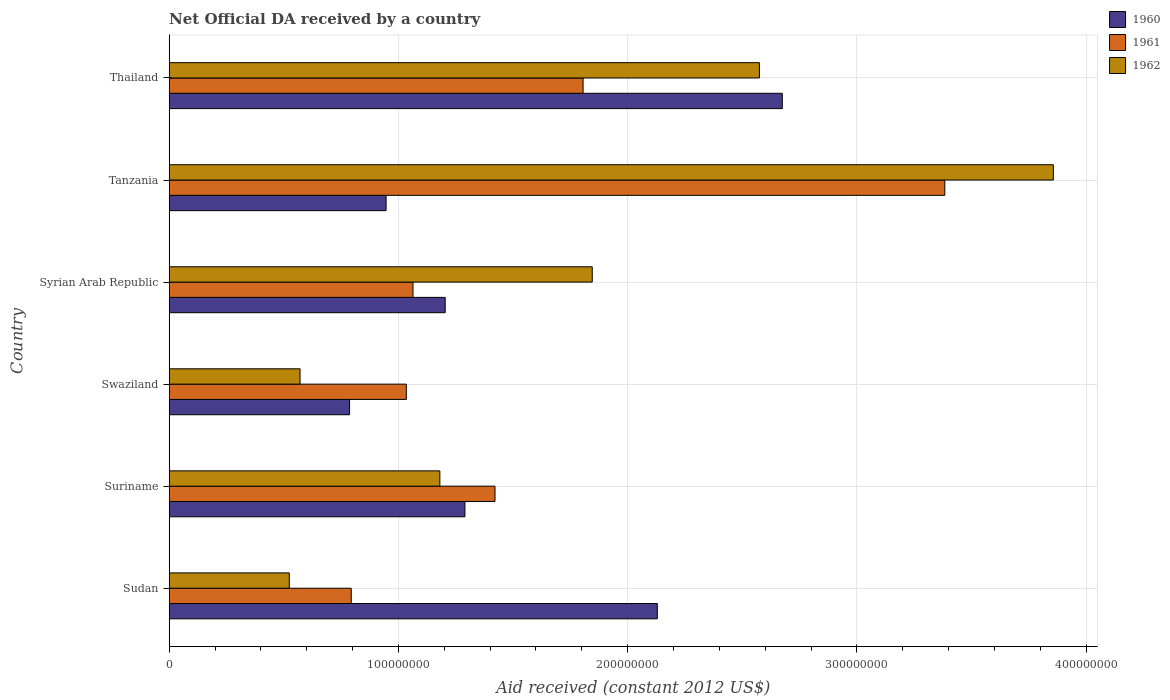How many different coloured bars are there?
Make the answer very short. 3. Are the number of bars per tick equal to the number of legend labels?
Provide a short and direct response. Yes. Are the number of bars on each tick of the Y-axis equal?
Keep it short and to the point. Yes. What is the label of the 5th group of bars from the top?
Keep it short and to the point. Suriname. In how many cases, is the number of bars for a given country not equal to the number of legend labels?
Give a very brief answer. 0. What is the net official development assistance aid received in 1961 in Syrian Arab Republic?
Ensure brevity in your answer.  1.06e+08. Across all countries, what is the maximum net official development assistance aid received in 1960?
Your answer should be very brief. 2.67e+08. Across all countries, what is the minimum net official development assistance aid received in 1960?
Make the answer very short. 7.87e+07. In which country was the net official development assistance aid received in 1961 maximum?
Provide a short and direct response. Tanzania. In which country was the net official development assistance aid received in 1960 minimum?
Make the answer very short. Swaziland. What is the total net official development assistance aid received in 1961 in the graph?
Keep it short and to the point. 9.50e+08. What is the difference between the net official development assistance aid received in 1961 in Sudan and that in Thailand?
Make the answer very short. -1.01e+08. What is the difference between the net official development assistance aid received in 1961 in Thailand and the net official development assistance aid received in 1962 in Suriname?
Your answer should be very brief. 6.25e+07. What is the average net official development assistance aid received in 1960 per country?
Ensure brevity in your answer.  1.51e+08. What is the difference between the net official development assistance aid received in 1962 and net official development assistance aid received in 1960 in Sudan?
Offer a terse response. -1.61e+08. What is the ratio of the net official development assistance aid received in 1960 in Swaziland to that in Thailand?
Offer a terse response. 0.29. Is the net official development assistance aid received in 1962 in Sudan less than that in Syrian Arab Republic?
Make the answer very short. Yes. What is the difference between the highest and the second highest net official development assistance aid received in 1960?
Give a very brief answer. 5.45e+07. What is the difference between the highest and the lowest net official development assistance aid received in 1960?
Ensure brevity in your answer.  1.89e+08. Is the sum of the net official development assistance aid received in 1962 in Sudan and Thailand greater than the maximum net official development assistance aid received in 1960 across all countries?
Make the answer very short. Yes. What does the 3rd bar from the top in Swaziland represents?
Make the answer very short. 1960. What does the 1st bar from the bottom in Thailand represents?
Your response must be concise. 1960. Are all the bars in the graph horizontal?
Provide a succinct answer. Yes. How many countries are there in the graph?
Your answer should be very brief. 6. Are the values on the major ticks of X-axis written in scientific E-notation?
Offer a very short reply. No. Does the graph contain any zero values?
Ensure brevity in your answer.  No. Does the graph contain grids?
Make the answer very short. Yes. How many legend labels are there?
Keep it short and to the point. 3. How are the legend labels stacked?
Provide a short and direct response. Vertical. What is the title of the graph?
Your response must be concise. Net Official DA received by a country. What is the label or title of the X-axis?
Provide a succinct answer. Aid received (constant 2012 US$). What is the Aid received (constant 2012 US$) of 1960 in Sudan?
Provide a succinct answer. 2.13e+08. What is the Aid received (constant 2012 US$) of 1961 in Sudan?
Your response must be concise. 7.94e+07. What is the Aid received (constant 2012 US$) of 1962 in Sudan?
Offer a terse response. 5.24e+07. What is the Aid received (constant 2012 US$) of 1960 in Suriname?
Offer a very short reply. 1.29e+08. What is the Aid received (constant 2012 US$) in 1961 in Suriname?
Your answer should be very brief. 1.42e+08. What is the Aid received (constant 2012 US$) of 1962 in Suriname?
Your response must be concise. 1.18e+08. What is the Aid received (constant 2012 US$) in 1960 in Swaziland?
Give a very brief answer. 7.87e+07. What is the Aid received (constant 2012 US$) of 1961 in Swaziland?
Make the answer very short. 1.03e+08. What is the Aid received (constant 2012 US$) of 1962 in Swaziland?
Your response must be concise. 5.71e+07. What is the Aid received (constant 2012 US$) in 1960 in Syrian Arab Republic?
Offer a very short reply. 1.20e+08. What is the Aid received (constant 2012 US$) in 1961 in Syrian Arab Republic?
Give a very brief answer. 1.06e+08. What is the Aid received (constant 2012 US$) of 1962 in Syrian Arab Republic?
Give a very brief answer. 1.85e+08. What is the Aid received (constant 2012 US$) of 1960 in Tanzania?
Provide a short and direct response. 9.46e+07. What is the Aid received (constant 2012 US$) of 1961 in Tanzania?
Make the answer very short. 3.38e+08. What is the Aid received (constant 2012 US$) in 1962 in Tanzania?
Offer a very short reply. 3.86e+08. What is the Aid received (constant 2012 US$) in 1960 in Thailand?
Offer a terse response. 2.67e+08. What is the Aid received (constant 2012 US$) of 1961 in Thailand?
Your answer should be compact. 1.81e+08. What is the Aid received (constant 2012 US$) in 1962 in Thailand?
Your answer should be compact. 2.57e+08. Across all countries, what is the maximum Aid received (constant 2012 US$) in 1960?
Keep it short and to the point. 2.67e+08. Across all countries, what is the maximum Aid received (constant 2012 US$) in 1961?
Your answer should be very brief. 3.38e+08. Across all countries, what is the maximum Aid received (constant 2012 US$) of 1962?
Your answer should be compact. 3.86e+08. Across all countries, what is the minimum Aid received (constant 2012 US$) in 1960?
Make the answer very short. 7.87e+07. Across all countries, what is the minimum Aid received (constant 2012 US$) in 1961?
Make the answer very short. 7.94e+07. Across all countries, what is the minimum Aid received (constant 2012 US$) of 1962?
Give a very brief answer. 5.24e+07. What is the total Aid received (constant 2012 US$) in 1960 in the graph?
Provide a succinct answer. 9.03e+08. What is the total Aid received (constant 2012 US$) in 1961 in the graph?
Offer a very short reply. 9.50e+08. What is the total Aid received (constant 2012 US$) in 1962 in the graph?
Give a very brief answer. 1.06e+09. What is the difference between the Aid received (constant 2012 US$) of 1960 in Sudan and that in Suriname?
Keep it short and to the point. 8.39e+07. What is the difference between the Aid received (constant 2012 US$) in 1961 in Sudan and that in Suriname?
Your response must be concise. -6.27e+07. What is the difference between the Aid received (constant 2012 US$) of 1962 in Sudan and that in Suriname?
Your answer should be compact. -6.57e+07. What is the difference between the Aid received (constant 2012 US$) of 1960 in Sudan and that in Swaziland?
Provide a succinct answer. 1.34e+08. What is the difference between the Aid received (constant 2012 US$) of 1961 in Sudan and that in Swaziland?
Keep it short and to the point. -2.40e+07. What is the difference between the Aid received (constant 2012 US$) of 1962 in Sudan and that in Swaziland?
Your answer should be very brief. -4.68e+06. What is the difference between the Aid received (constant 2012 US$) of 1960 in Sudan and that in Syrian Arab Republic?
Provide a short and direct response. 9.26e+07. What is the difference between the Aid received (constant 2012 US$) in 1961 in Sudan and that in Syrian Arab Republic?
Give a very brief answer. -2.69e+07. What is the difference between the Aid received (constant 2012 US$) of 1962 in Sudan and that in Syrian Arab Republic?
Make the answer very short. -1.32e+08. What is the difference between the Aid received (constant 2012 US$) in 1960 in Sudan and that in Tanzania?
Your answer should be very brief. 1.18e+08. What is the difference between the Aid received (constant 2012 US$) of 1961 in Sudan and that in Tanzania?
Provide a short and direct response. -2.59e+08. What is the difference between the Aid received (constant 2012 US$) in 1962 in Sudan and that in Tanzania?
Give a very brief answer. -3.33e+08. What is the difference between the Aid received (constant 2012 US$) in 1960 in Sudan and that in Thailand?
Provide a succinct answer. -5.45e+07. What is the difference between the Aid received (constant 2012 US$) in 1961 in Sudan and that in Thailand?
Make the answer very short. -1.01e+08. What is the difference between the Aid received (constant 2012 US$) in 1962 in Sudan and that in Thailand?
Give a very brief answer. -2.05e+08. What is the difference between the Aid received (constant 2012 US$) in 1960 in Suriname and that in Swaziland?
Ensure brevity in your answer.  5.03e+07. What is the difference between the Aid received (constant 2012 US$) in 1961 in Suriname and that in Swaziland?
Ensure brevity in your answer.  3.87e+07. What is the difference between the Aid received (constant 2012 US$) of 1962 in Suriname and that in Swaziland?
Your response must be concise. 6.10e+07. What is the difference between the Aid received (constant 2012 US$) of 1960 in Suriname and that in Syrian Arab Republic?
Give a very brief answer. 8.62e+06. What is the difference between the Aid received (constant 2012 US$) in 1961 in Suriname and that in Syrian Arab Republic?
Your answer should be very brief. 3.58e+07. What is the difference between the Aid received (constant 2012 US$) of 1962 in Suriname and that in Syrian Arab Republic?
Offer a very short reply. -6.65e+07. What is the difference between the Aid received (constant 2012 US$) of 1960 in Suriname and that in Tanzania?
Offer a terse response. 3.44e+07. What is the difference between the Aid received (constant 2012 US$) in 1961 in Suriname and that in Tanzania?
Give a very brief answer. -1.96e+08. What is the difference between the Aid received (constant 2012 US$) in 1962 in Suriname and that in Tanzania?
Your answer should be compact. -2.68e+08. What is the difference between the Aid received (constant 2012 US$) of 1960 in Suriname and that in Thailand?
Your response must be concise. -1.38e+08. What is the difference between the Aid received (constant 2012 US$) of 1961 in Suriname and that in Thailand?
Your answer should be compact. -3.84e+07. What is the difference between the Aid received (constant 2012 US$) of 1962 in Suriname and that in Thailand?
Provide a short and direct response. -1.39e+08. What is the difference between the Aid received (constant 2012 US$) in 1960 in Swaziland and that in Syrian Arab Republic?
Your response must be concise. -4.17e+07. What is the difference between the Aid received (constant 2012 US$) of 1961 in Swaziland and that in Syrian Arab Republic?
Your answer should be very brief. -2.90e+06. What is the difference between the Aid received (constant 2012 US$) in 1962 in Swaziland and that in Syrian Arab Republic?
Offer a very short reply. -1.27e+08. What is the difference between the Aid received (constant 2012 US$) of 1960 in Swaziland and that in Tanzania?
Offer a terse response. -1.59e+07. What is the difference between the Aid received (constant 2012 US$) in 1961 in Swaziland and that in Tanzania?
Your response must be concise. -2.35e+08. What is the difference between the Aid received (constant 2012 US$) of 1962 in Swaziland and that in Tanzania?
Give a very brief answer. -3.29e+08. What is the difference between the Aid received (constant 2012 US$) in 1960 in Swaziland and that in Thailand?
Your response must be concise. -1.89e+08. What is the difference between the Aid received (constant 2012 US$) of 1961 in Swaziland and that in Thailand?
Provide a short and direct response. -7.71e+07. What is the difference between the Aid received (constant 2012 US$) in 1962 in Swaziland and that in Thailand?
Offer a very short reply. -2.00e+08. What is the difference between the Aid received (constant 2012 US$) of 1960 in Syrian Arab Republic and that in Tanzania?
Provide a succinct answer. 2.58e+07. What is the difference between the Aid received (constant 2012 US$) in 1961 in Syrian Arab Republic and that in Tanzania?
Offer a terse response. -2.32e+08. What is the difference between the Aid received (constant 2012 US$) of 1962 in Syrian Arab Republic and that in Tanzania?
Provide a short and direct response. -2.01e+08. What is the difference between the Aid received (constant 2012 US$) in 1960 in Syrian Arab Republic and that in Thailand?
Keep it short and to the point. -1.47e+08. What is the difference between the Aid received (constant 2012 US$) of 1961 in Syrian Arab Republic and that in Thailand?
Ensure brevity in your answer.  -7.42e+07. What is the difference between the Aid received (constant 2012 US$) of 1962 in Syrian Arab Republic and that in Thailand?
Give a very brief answer. -7.29e+07. What is the difference between the Aid received (constant 2012 US$) in 1960 in Tanzania and that in Thailand?
Offer a very short reply. -1.73e+08. What is the difference between the Aid received (constant 2012 US$) in 1961 in Tanzania and that in Thailand?
Your answer should be compact. 1.58e+08. What is the difference between the Aid received (constant 2012 US$) in 1962 in Tanzania and that in Thailand?
Give a very brief answer. 1.28e+08. What is the difference between the Aid received (constant 2012 US$) of 1960 in Sudan and the Aid received (constant 2012 US$) of 1961 in Suriname?
Your response must be concise. 7.08e+07. What is the difference between the Aid received (constant 2012 US$) in 1960 in Sudan and the Aid received (constant 2012 US$) in 1962 in Suriname?
Your response must be concise. 9.49e+07. What is the difference between the Aid received (constant 2012 US$) of 1961 in Sudan and the Aid received (constant 2012 US$) of 1962 in Suriname?
Give a very brief answer. -3.87e+07. What is the difference between the Aid received (constant 2012 US$) in 1960 in Sudan and the Aid received (constant 2012 US$) in 1961 in Swaziland?
Your answer should be very brief. 1.10e+08. What is the difference between the Aid received (constant 2012 US$) of 1960 in Sudan and the Aid received (constant 2012 US$) of 1962 in Swaziland?
Provide a short and direct response. 1.56e+08. What is the difference between the Aid received (constant 2012 US$) in 1961 in Sudan and the Aid received (constant 2012 US$) in 1962 in Swaziland?
Your answer should be very brief. 2.23e+07. What is the difference between the Aid received (constant 2012 US$) of 1960 in Sudan and the Aid received (constant 2012 US$) of 1961 in Syrian Arab Republic?
Your response must be concise. 1.07e+08. What is the difference between the Aid received (constant 2012 US$) in 1960 in Sudan and the Aid received (constant 2012 US$) in 1962 in Syrian Arab Republic?
Keep it short and to the point. 2.84e+07. What is the difference between the Aid received (constant 2012 US$) in 1961 in Sudan and the Aid received (constant 2012 US$) in 1962 in Syrian Arab Republic?
Give a very brief answer. -1.05e+08. What is the difference between the Aid received (constant 2012 US$) of 1960 in Sudan and the Aid received (constant 2012 US$) of 1961 in Tanzania?
Provide a succinct answer. -1.25e+08. What is the difference between the Aid received (constant 2012 US$) in 1960 in Sudan and the Aid received (constant 2012 US$) in 1962 in Tanzania?
Your answer should be compact. -1.73e+08. What is the difference between the Aid received (constant 2012 US$) of 1961 in Sudan and the Aid received (constant 2012 US$) of 1962 in Tanzania?
Keep it short and to the point. -3.06e+08. What is the difference between the Aid received (constant 2012 US$) in 1960 in Sudan and the Aid received (constant 2012 US$) in 1961 in Thailand?
Keep it short and to the point. 3.24e+07. What is the difference between the Aid received (constant 2012 US$) in 1960 in Sudan and the Aid received (constant 2012 US$) in 1962 in Thailand?
Keep it short and to the point. -4.45e+07. What is the difference between the Aid received (constant 2012 US$) in 1961 in Sudan and the Aid received (constant 2012 US$) in 1962 in Thailand?
Your answer should be compact. -1.78e+08. What is the difference between the Aid received (constant 2012 US$) of 1960 in Suriname and the Aid received (constant 2012 US$) of 1961 in Swaziland?
Provide a short and direct response. 2.56e+07. What is the difference between the Aid received (constant 2012 US$) of 1960 in Suriname and the Aid received (constant 2012 US$) of 1962 in Swaziland?
Give a very brief answer. 7.19e+07. What is the difference between the Aid received (constant 2012 US$) of 1961 in Suriname and the Aid received (constant 2012 US$) of 1962 in Swaziland?
Your answer should be very brief. 8.50e+07. What is the difference between the Aid received (constant 2012 US$) of 1960 in Suriname and the Aid received (constant 2012 US$) of 1961 in Syrian Arab Republic?
Give a very brief answer. 2.27e+07. What is the difference between the Aid received (constant 2012 US$) in 1960 in Suriname and the Aid received (constant 2012 US$) in 1962 in Syrian Arab Republic?
Give a very brief answer. -5.55e+07. What is the difference between the Aid received (constant 2012 US$) in 1961 in Suriname and the Aid received (constant 2012 US$) in 1962 in Syrian Arab Republic?
Make the answer very short. -4.24e+07. What is the difference between the Aid received (constant 2012 US$) of 1960 in Suriname and the Aid received (constant 2012 US$) of 1961 in Tanzania?
Provide a short and direct response. -2.09e+08. What is the difference between the Aid received (constant 2012 US$) of 1960 in Suriname and the Aid received (constant 2012 US$) of 1962 in Tanzania?
Keep it short and to the point. -2.57e+08. What is the difference between the Aid received (constant 2012 US$) of 1961 in Suriname and the Aid received (constant 2012 US$) of 1962 in Tanzania?
Ensure brevity in your answer.  -2.44e+08. What is the difference between the Aid received (constant 2012 US$) in 1960 in Suriname and the Aid received (constant 2012 US$) in 1961 in Thailand?
Make the answer very short. -5.15e+07. What is the difference between the Aid received (constant 2012 US$) of 1960 in Suriname and the Aid received (constant 2012 US$) of 1962 in Thailand?
Offer a terse response. -1.28e+08. What is the difference between the Aid received (constant 2012 US$) in 1961 in Suriname and the Aid received (constant 2012 US$) in 1962 in Thailand?
Keep it short and to the point. -1.15e+08. What is the difference between the Aid received (constant 2012 US$) of 1960 in Swaziland and the Aid received (constant 2012 US$) of 1961 in Syrian Arab Republic?
Ensure brevity in your answer.  -2.77e+07. What is the difference between the Aid received (constant 2012 US$) of 1960 in Swaziland and the Aid received (constant 2012 US$) of 1962 in Syrian Arab Republic?
Keep it short and to the point. -1.06e+08. What is the difference between the Aid received (constant 2012 US$) in 1961 in Swaziland and the Aid received (constant 2012 US$) in 1962 in Syrian Arab Republic?
Give a very brief answer. -8.11e+07. What is the difference between the Aid received (constant 2012 US$) of 1960 in Swaziland and the Aid received (constant 2012 US$) of 1961 in Tanzania?
Make the answer very short. -2.60e+08. What is the difference between the Aid received (constant 2012 US$) of 1960 in Swaziland and the Aid received (constant 2012 US$) of 1962 in Tanzania?
Provide a succinct answer. -3.07e+08. What is the difference between the Aid received (constant 2012 US$) in 1961 in Swaziland and the Aid received (constant 2012 US$) in 1962 in Tanzania?
Make the answer very short. -2.82e+08. What is the difference between the Aid received (constant 2012 US$) of 1960 in Swaziland and the Aid received (constant 2012 US$) of 1961 in Thailand?
Ensure brevity in your answer.  -1.02e+08. What is the difference between the Aid received (constant 2012 US$) of 1960 in Swaziland and the Aid received (constant 2012 US$) of 1962 in Thailand?
Provide a succinct answer. -1.79e+08. What is the difference between the Aid received (constant 2012 US$) in 1961 in Swaziland and the Aid received (constant 2012 US$) in 1962 in Thailand?
Provide a short and direct response. -1.54e+08. What is the difference between the Aid received (constant 2012 US$) in 1960 in Syrian Arab Republic and the Aid received (constant 2012 US$) in 1961 in Tanzania?
Offer a very short reply. -2.18e+08. What is the difference between the Aid received (constant 2012 US$) of 1960 in Syrian Arab Republic and the Aid received (constant 2012 US$) of 1962 in Tanzania?
Provide a succinct answer. -2.65e+08. What is the difference between the Aid received (constant 2012 US$) in 1961 in Syrian Arab Republic and the Aid received (constant 2012 US$) in 1962 in Tanzania?
Give a very brief answer. -2.79e+08. What is the difference between the Aid received (constant 2012 US$) of 1960 in Syrian Arab Republic and the Aid received (constant 2012 US$) of 1961 in Thailand?
Your response must be concise. -6.02e+07. What is the difference between the Aid received (constant 2012 US$) of 1960 in Syrian Arab Republic and the Aid received (constant 2012 US$) of 1962 in Thailand?
Give a very brief answer. -1.37e+08. What is the difference between the Aid received (constant 2012 US$) in 1961 in Syrian Arab Republic and the Aid received (constant 2012 US$) in 1962 in Thailand?
Provide a short and direct response. -1.51e+08. What is the difference between the Aid received (constant 2012 US$) of 1960 in Tanzania and the Aid received (constant 2012 US$) of 1961 in Thailand?
Ensure brevity in your answer.  -8.59e+07. What is the difference between the Aid received (constant 2012 US$) in 1960 in Tanzania and the Aid received (constant 2012 US$) in 1962 in Thailand?
Give a very brief answer. -1.63e+08. What is the difference between the Aid received (constant 2012 US$) in 1961 in Tanzania and the Aid received (constant 2012 US$) in 1962 in Thailand?
Provide a succinct answer. 8.09e+07. What is the average Aid received (constant 2012 US$) of 1960 per country?
Your answer should be compact. 1.51e+08. What is the average Aid received (constant 2012 US$) of 1961 per country?
Provide a short and direct response. 1.58e+08. What is the average Aid received (constant 2012 US$) in 1962 per country?
Offer a very short reply. 1.76e+08. What is the difference between the Aid received (constant 2012 US$) in 1960 and Aid received (constant 2012 US$) in 1961 in Sudan?
Keep it short and to the point. 1.34e+08. What is the difference between the Aid received (constant 2012 US$) in 1960 and Aid received (constant 2012 US$) in 1962 in Sudan?
Your answer should be compact. 1.61e+08. What is the difference between the Aid received (constant 2012 US$) of 1961 and Aid received (constant 2012 US$) of 1962 in Sudan?
Ensure brevity in your answer.  2.70e+07. What is the difference between the Aid received (constant 2012 US$) in 1960 and Aid received (constant 2012 US$) in 1961 in Suriname?
Make the answer very short. -1.31e+07. What is the difference between the Aid received (constant 2012 US$) of 1960 and Aid received (constant 2012 US$) of 1962 in Suriname?
Make the answer very short. 1.09e+07. What is the difference between the Aid received (constant 2012 US$) of 1961 and Aid received (constant 2012 US$) of 1962 in Suriname?
Your answer should be compact. 2.40e+07. What is the difference between the Aid received (constant 2012 US$) in 1960 and Aid received (constant 2012 US$) in 1961 in Swaziland?
Offer a very short reply. -2.48e+07. What is the difference between the Aid received (constant 2012 US$) in 1960 and Aid received (constant 2012 US$) in 1962 in Swaziland?
Your response must be concise. 2.16e+07. What is the difference between the Aid received (constant 2012 US$) in 1961 and Aid received (constant 2012 US$) in 1962 in Swaziland?
Your answer should be compact. 4.64e+07. What is the difference between the Aid received (constant 2012 US$) in 1960 and Aid received (constant 2012 US$) in 1961 in Syrian Arab Republic?
Provide a short and direct response. 1.40e+07. What is the difference between the Aid received (constant 2012 US$) in 1960 and Aid received (constant 2012 US$) in 1962 in Syrian Arab Republic?
Offer a terse response. -6.42e+07. What is the difference between the Aid received (constant 2012 US$) in 1961 and Aid received (constant 2012 US$) in 1962 in Syrian Arab Republic?
Offer a very short reply. -7.82e+07. What is the difference between the Aid received (constant 2012 US$) of 1960 and Aid received (constant 2012 US$) of 1961 in Tanzania?
Your answer should be compact. -2.44e+08. What is the difference between the Aid received (constant 2012 US$) of 1960 and Aid received (constant 2012 US$) of 1962 in Tanzania?
Give a very brief answer. -2.91e+08. What is the difference between the Aid received (constant 2012 US$) of 1961 and Aid received (constant 2012 US$) of 1962 in Tanzania?
Your answer should be very brief. -4.74e+07. What is the difference between the Aid received (constant 2012 US$) in 1960 and Aid received (constant 2012 US$) in 1961 in Thailand?
Provide a succinct answer. 8.69e+07. What is the difference between the Aid received (constant 2012 US$) of 1960 and Aid received (constant 2012 US$) of 1962 in Thailand?
Keep it short and to the point. 9.99e+06. What is the difference between the Aid received (constant 2012 US$) in 1961 and Aid received (constant 2012 US$) in 1962 in Thailand?
Make the answer very short. -7.69e+07. What is the ratio of the Aid received (constant 2012 US$) of 1960 in Sudan to that in Suriname?
Make the answer very short. 1.65. What is the ratio of the Aid received (constant 2012 US$) in 1961 in Sudan to that in Suriname?
Ensure brevity in your answer.  0.56. What is the ratio of the Aid received (constant 2012 US$) of 1962 in Sudan to that in Suriname?
Ensure brevity in your answer.  0.44. What is the ratio of the Aid received (constant 2012 US$) in 1960 in Sudan to that in Swaziland?
Offer a terse response. 2.71. What is the ratio of the Aid received (constant 2012 US$) in 1961 in Sudan to that in Swaziland?
Your answer should be very brief. 0.77. What is the ratio of the Aid received (constant 2012 US$) of 1962 in Sudan to that in Swaziland?
Ensure brevity in your answer.  0.92. What is the ratio of the Aid received (constant 2012 US$) of 1960 in Sudan to that in Syrian Arab Republic?
Ensure brevity in your answer.  1.77. What is the ratio of the Aid received (constant 2012 US$) of 1961 in Sudan to that in Syrian Arab Republic?
Make the answer very short. 0.75. What is the ratio of the Aid received (constant 2012 US$) of 1962 in Sudan to that in Syrian Arab Republic?
Make the answer very short. 0.28. What is the ratio of the Aid received (constant 2012 US$) of 1960 in Sudan to that in Tanzania?
Ensure brevity in your answer.  2.25. What is the ratio of the Aid received (constant 2012 US$) of 1961 in Sudan to that in Tanzania?
Your answer should be compact. 0.23. What is the ratio of the Aid received (constant 2012 US$) of 1962 in Sudan to that in Tanzania?
Your answer should be compact. 0.14. What is the ratio of the Aid received (constant 2012 US$) in 1960 in Sudan to that in Thailand?
Provide a short and direct response. 0.8. What is the ratio of the Aid received (constant 2012 US$) of 1961 in Sudan to that in Thailand?
Provide a succinct answer. 0.44. What is the ratio of the Aid received (constant 2012 US$) in 1962 in Sudan to that in Thailand?
Give a very brief answer. 0.2. What is the ratio of the Aid received (constant 2012 US$) in 1960 in Suriname to that in Swaziland?
Provide a short and direct response. 1.64. What is the ratio of the Aid received (constant 2012 US$) in 1961 in Suriname to that in Swaziland?
Your answer should be very brief. 1.37. What is the ratio of the Aid received (constant 2012 US$) in 1962 in Suriname to that in Swaziland?
Provide a succinct answer. 2.07. What is the ratio of the Aid received (constant 2012 US$) in 1960 in Suriname to that in Syrian Arab Republic?
Your response must be concise. 1.07. What is the ratio of the Aid received (constant 2012 US$) of 1961 in Suriname to that in Syrian Arab Republic?
Your answer should be very brief. 1.34. What is the ratio of the Aid received (constant 2012 US$) in 1962 in Suriname to that in Syrian Arab Republic?
Your answer should be very brief. 0.64. What is the ratio of the Aid received (constant 2012 US$) of 1960 in Suriname to that in Tanzania?
Provide a succinct answer. 1.36. What is the ratio of the Aid received (constant 2012 US$) in 1961 in Suriname to that in Tanzania?
Offer a terse response. 0.42. What is the ratio of the Aid received (constant 2012 US$) in 1962 in Suriname to that in Tanzania?
Your answer should be compact. 0.31. What is the ratio of the Aid received (constant 2012 US$) of 1960 in Suriname to that in Thailand?
Make the answer very short. 0.48. What is the ratio of the Aid received (constant 2012 US$) in 1961 in Suriname to that in Thailand?
Keep it short and to the point. 0.79. What is the ratio of the Aid received (constant 2012 US$) of 1962 in Suriname to that in Thailand?
Give a very brief answer. 0.46. What is the ratio of the Aid received (constant 2012 US$) of 1960 in Swaziland to that in Syrian Arab Republic?
Keep it short and to the point. 0.65. What is the ratio of the Aid received (constant 2012 US$) of 1961 in Swaziland to that in Syrian Arab Republic?
Your answer should be compact. 0.97. What is the ratio of the Aid received (constant 2012 US$) of 1962 in Swaziland to that in Syrian Arab Republic?
Your answer should be very brief. 0.31. What is the ratio of the Aid received (constant 2012 US$) in 1960 in Swaziland to that in Tanzania?
Offer a terse response. 0.83. What is the ratio of the Aid received (constant 2012 US$) of 1961 in Swaziland to that in Tanzania?
Provide a short and direct response. 0.31. What is the ratio of the Aid received (constant 2012 US$) of 1962 in Swaziland to that in Tanzania?
Provide a succinct answer. 0.15. What is the ratio of the Aid received (constant 2012 US$) of 1960 in Swaziland to that in Thailand?
Your response must be concise. 0.29. What is the ratio of the Aid received (constant 2012 US$) in 1961 in Swaziland to that in Thailand?
Provide a succinct answer. 0.57. What is the ratio of the Aid received (constant 2012 US$) of 1962 in Swaziland to that in Thailand?
Keep it short and to the point. 0.22. What is the ratio of the Aid received (constant 2012 US$) of 1960 in Syrian Arab Republic to that in Tanzania?
Offer a terse response. 1.27. What is the ratio of the Aid received (constant 2012 US$) in 1961 in Syrian Arab Republic to that in Tanzania?
Your answer should be very brief. 0.31. What is the ratio of the Aid received (constant 2012 US$) in 1962 in Syrian Arab Republic to that in Tanzania?
Ensure brevity in your answer.  0.48. What is the ratio of the Aid received (constant 2012 US$) in 1960 in Syrian Arab Republic to that in Thailand?
Provide a short and direct response. 0.45. What is the ratio of the Aid received (constant 2012 US$) in 1961 in Syrian Arab Republic to that in Thailand?
Your answer should be very brief. 0.59. What is the ratio of the Aid received (constant 2012 US$) in 1962 in Syrian Arab Republic to that in Thailand?
Give a very brief answer. 0.72. What is the ratio of the Aid received (constant 2012 US$) of 1960 in Tanzania to that in Thailand?
Ensure brevity in your answer.  0.35. What is the ratio of the Aid received (constant 2012 US$) in 1961 in Tanzania to that in Thailand?
Offer a very short reply. 1.87. What is the ratio of the Aid received (constant 2012 US$) in 1962 in Tanzania to that in Thailand?
Your answer should be very brief. 1.5. What is the difference between the highest and the second highest Aid received (constant 2012 US$) in 1960?
Keep it short and to the point. 5.45e+07. What is the difference between the highest and the second highest Aid received (constant 2012 US$) in 1961?
Provide a short and direct response. 1.58e+08. What is the difference between the highest and the second highest Aid received (constant 2012 US$) in 1962?
Give a very brief answer. 1.28e+08. What is the difference between the highest and the lowest Aid received (constant 2012 US$) of 1960?
Give a very brief answer. 1.89e+08. What is the difference between the highest and the lowest Aid received (constant 2012 US$) in 1961?
Your answer should be very brief. 2.59e+08. What is the difference between the highest and the lowest Aid received (constant 2012 US$) in 1962?
Ensure brevity in your answer.  3.33e+08. 